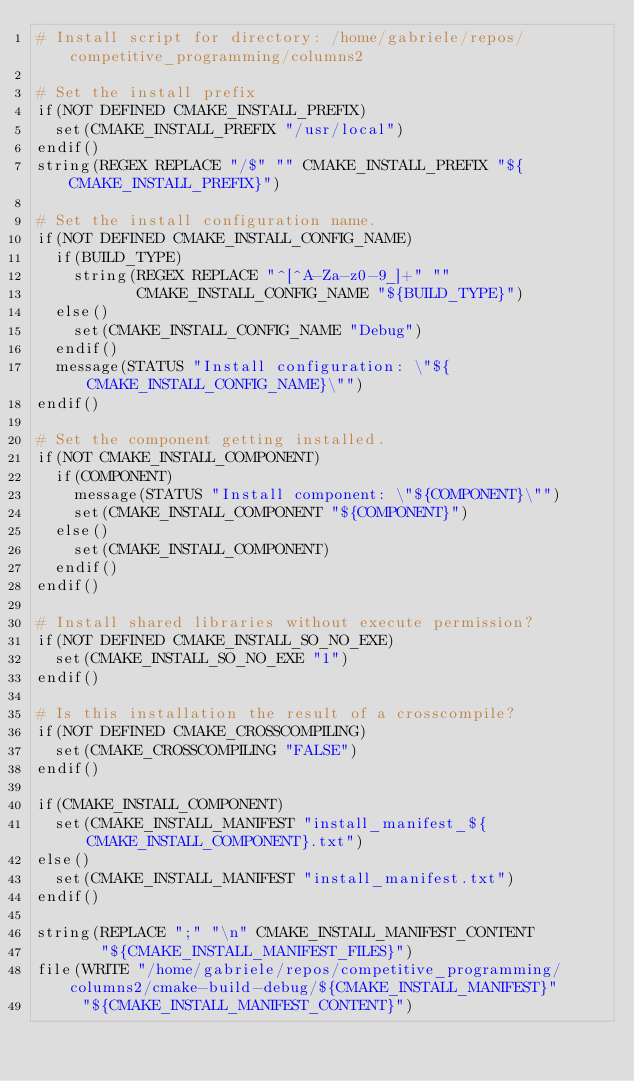Convert code to text. <code><loc_0><loc_0><loc_500><loc_500><_CMake_># Install script for directory: /home/gabriele/repos/competitive_programming/columns2

# Set the install prefix
if(NOT DEFINED CMAKE_INSTALL_PREFIX)
  set(CMAKE_INSTALL_PREFIX "/usr/local")
endif()
string(REGEX REPLACE "/$" "" CMAKE_INSTALL_PREFIX "${CMAKE_INSTALL_PREFIX}")

# Set the install configuration name.
if(NOT DEFINED CMAKE_INSTALL_CONFIG_NAME)
  if(BUILD_TYPE)
    string(REGEX REPLACE "^[^A-Za-z0-9_]+" ""
           CMAKE_INSTALL_CONFIG_NAME "${BUILD_TYPE}")
  else()
    set(CMAKE_INSTALL_CONFIG_NAME "Debug")
  endif()
  message(STATUS "Install configuration: \"${CMAKE_INSTALL_CONFIG_NAME}\"")
endif()

# Set the component getting installed.
if(NOT CMAKE_INSTALL_COMPONENT)
  if(COMPONENT)
    message(STATUS "Install component: \"${COMPONENT}\"")
    set(CMAKE_INSTALL_COMPONENT "${COMPONENT}")
  else()
    set(CMAKE_INSTALL_COMPONENT)
  endif()
endif()

# Install shared libraries without execute permission?
if(NOT DEFINED CMAKE_INSTALL_SO_NO_EXE)
  set(CMAKE_INSTALL_SO_NO_EXE "1")
endif()

# Is this installation the result of a crosscompile?
if(NOT DEFINED CMAKE_CROSSCOMPILING)
  set(CMAKE_CROSSCOMPILING "FALSE")
endif()

if(CMAKE_INSTALL_COMPONENT)
  set(CMAKE_INSTALL_MANIFEST "install_manifest_${CMAKE_INSTALL_COMPONENT}.txt")
else()
  set(CMAKE_INSTALL_MANIFEST "install_manifest.txt")
endif()

string(REPLACE ";" "\n" CMAKE_INSTALL_MANIFEST_CONTENT
       "${CMAKE_INSTALL_MANIFEST_FILES}")
file(WRITE "/home/gabriele/repos/competitive_programming/columns2/cmake-build-debug/${CMAKE_INSTALL_MANIFEST}"
     "${CMAKE_INSTALL_MANIFEST_CONTENT}")
</code> 